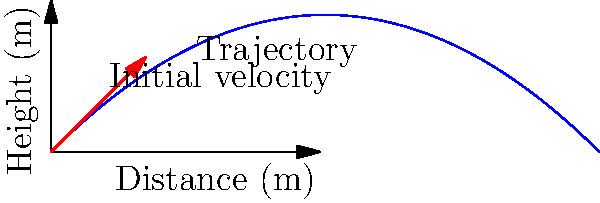In the graph above, a baseball is thrown with an initial velocity of 40 m/s at a 45-degree angle. What is the maximum height reached by the baseball, and how does this relate to the concept of conservation of energy in biomechanics? To solve this problem, we'll follow these steps:

1) The maximum height is reached when the vertical velocity becomes zero. We can use the equation:

   $$v_y = v_0 \sin(\theta) - gt$$

   where $v_y$ is the vertical velocity, $v_0$ is the initial velocity, $\theta$ is the launch angle, $g$ is the acceleration due to gravity, and $t$ is time.

2) Set $v_y = 0$ and solve for $t$:

   $$0 = v_0 \sin(\theta) - gt$$
   $$t = \frac{v_0 \sin(\theta)}{g}$$

3) Substitute the given values:
   
   $$t = \frac{40 \sin(45°)}{9.81} \approx 2.89 \text{ seconds}$$

4) Now use the equation for height:

   $$y = v_0 \sin(\theta)t - \frac{1}{2}gt^2$$

5) Substitute the time we found:

   $$y = 40 \sin(45°)(2.89) - \frac{1}{2}(9.81)(2.89)^2 \approx 40.8 \text{ meters}$$

6) This relates to conservation of energy because at the maximum height, all of the initial kinetic energy in the vertical direction has been converted to potential energy. The total energy (kinetic + potential) remains constant throughout the throw, demonstrating the principle of energy conservation in biomechanics.

7) At the start: Total Energy = Kinetic Energy (KE) + Potential Energy (PE)
   
   $$E_{\text{total}} = \frac{1}{2}mv_0^2 + 0$$

8) At max height: Total Energy = Kinetic Energy (horizontal only) + Potential Energy
   
   $$E_{\text{total}} = \frac{1}{2}m(v_0\cos(\theta))^2 + mgh_{\text{max}}$$

   where $h_{\text{max}}$ is the maximum height we calculated.

This conservation of energy principle is crucial in understanding the biomechanics of throwing, as it helps explain how the initial force applied by the thrower translates into the ball's trajectory.
Answer: 40.8 meters; at max height, vertical KE converts to PE 